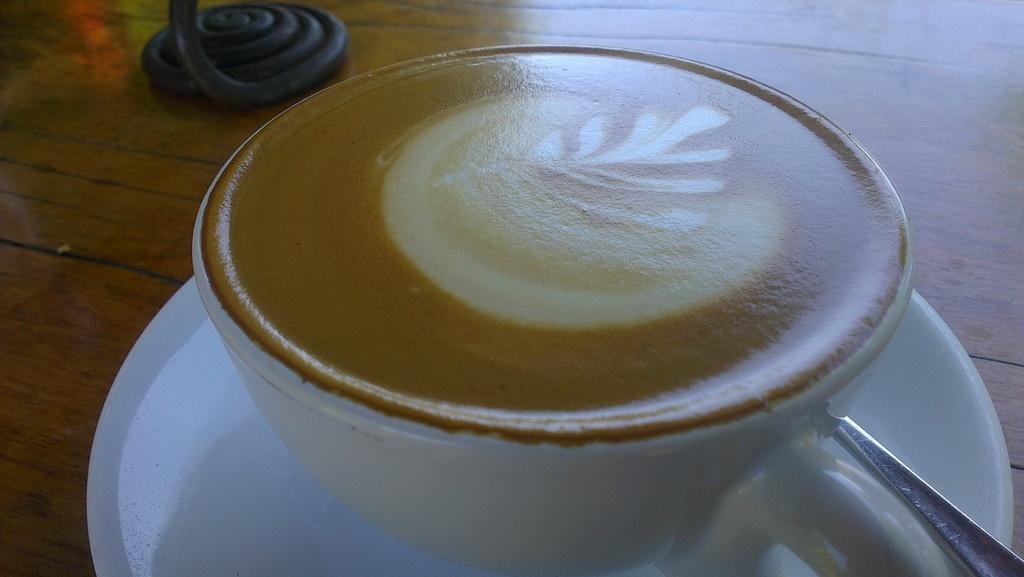In one or two sentences, can you explain what this image depicts? In the middle of this image, there is a white color cup having a coffee on a white color saucer, on which there is a spoon. This sauce is placed on a table, on which there is an object. 